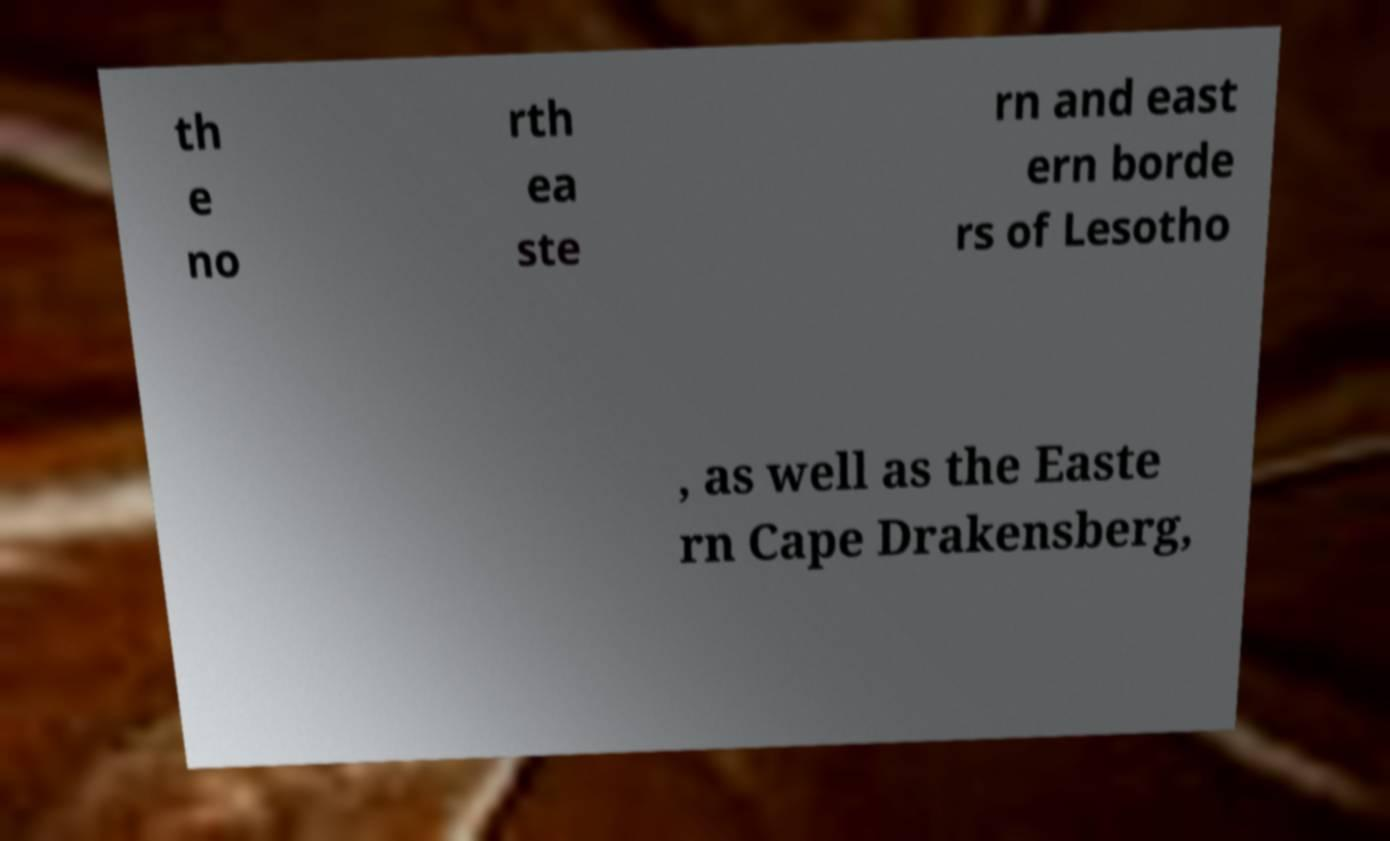For documentation purposes, I need the text within this image transcribed. Could you provide that? th e no rth ea ste rn and east ern borde rs of Lesotho , as well as the Easte rn Cape Drakensberg, 